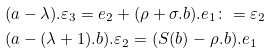<formula> <loc_0><loc_0><loc_500><loc_500>& ( a - \lambda ) . \varepsilon _ { 3 } = e _ { 2 } + ( \rho + \sigma . b ) . e _ { 1 } \colon = \varepsilon _ { 2 } \\ & ( a - ( \lambda + 1 ) . b ) . \varepsilon _ { 2 } = ( S ( b ) - \rho . b ) . e _ { 1 }</formula> 